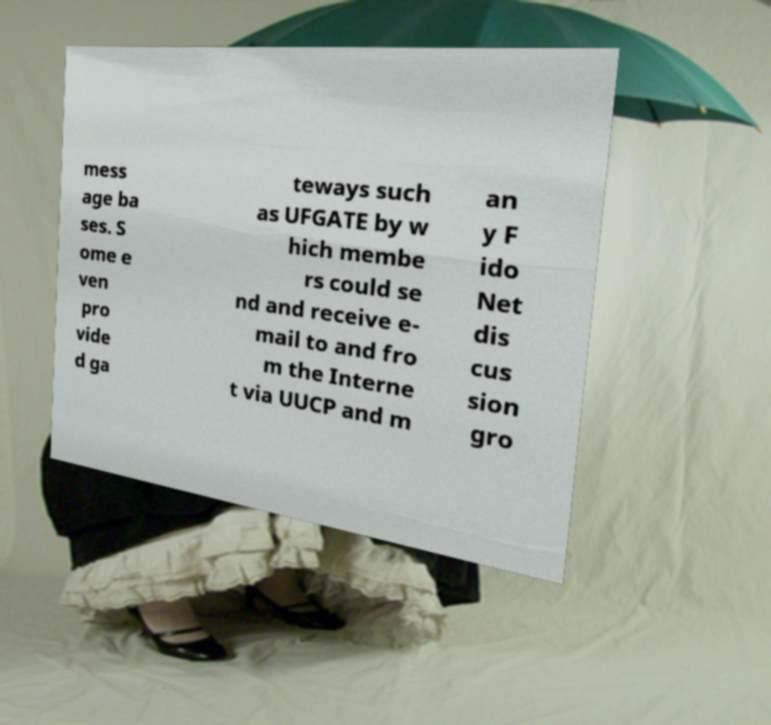Could you extract and type out the text from this image? mess age ba ses. S ome e ven pro vide d ga teways such as UFGATE by w hich membe rs could se nd and receive e- mail to and fro m the Interne t via UUCP and m an y F ido Net dis cus sion gro 